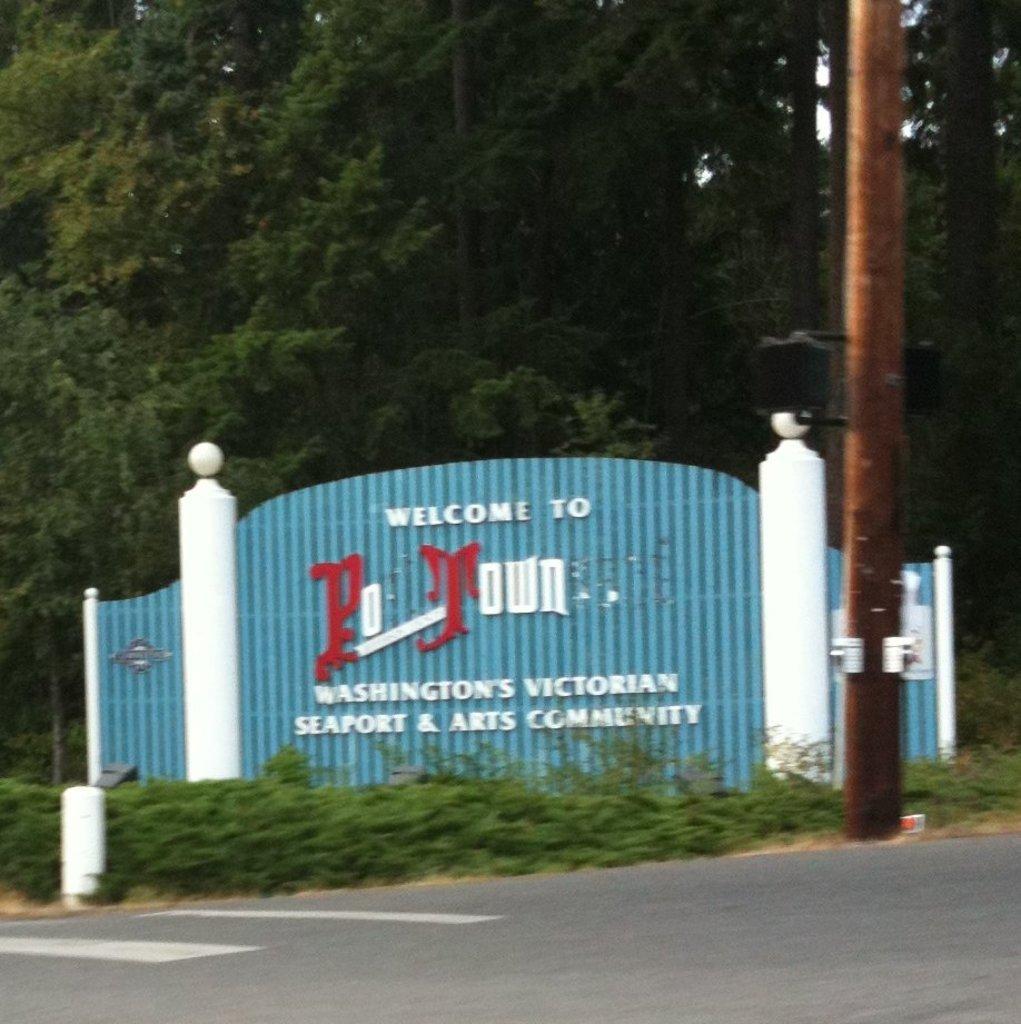Can you describe this image briefly? To the bottom of the image there is a road. Behind the road there is grass. Behind the grass there are two white pillars with blue gate and a name on it. In the background there are trees and to the right side of the image there is a pole. 